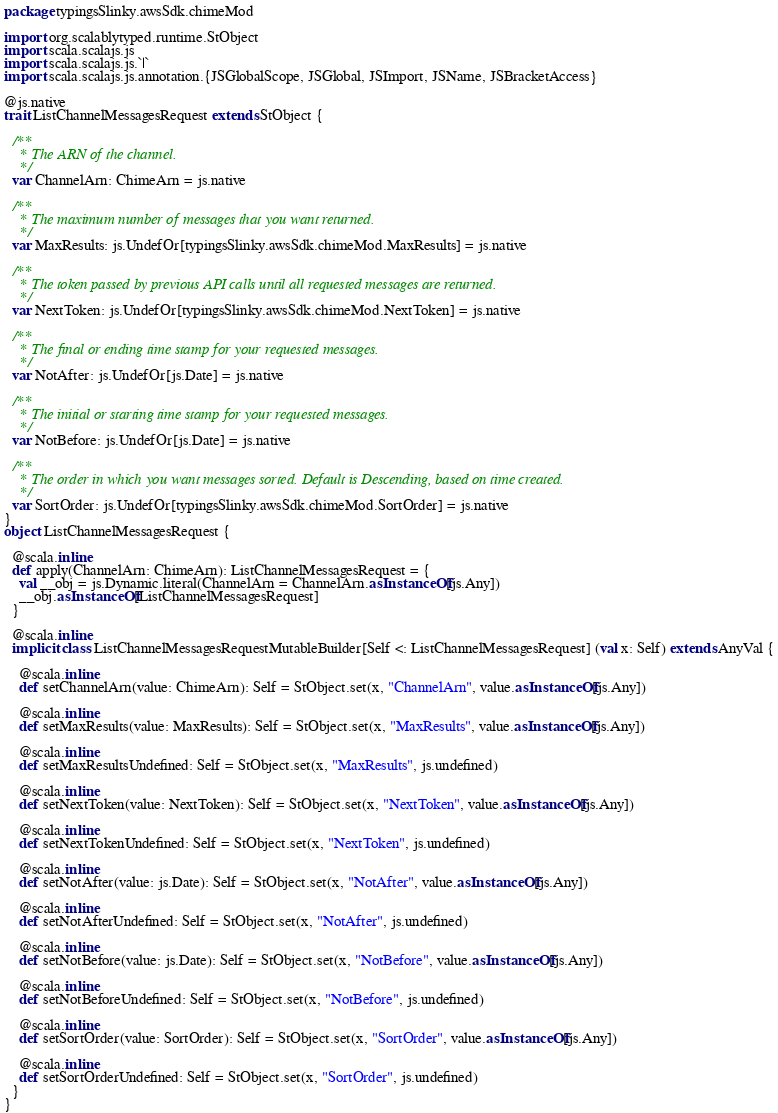<code> <loc_0><loc_0><loc_500><loc_500><_Scala_>package typingsSlinky.awsSdk.chimeMod

import org.scalablytyped.runtime.StObject
import scala.scalajs.js
import scala.scalajs.js.`|`
import scala.scalajs.js.annotation.{JSGlobalScope, JSGlobal, JSImport, JSName, JSBracketAccess}

@js.native
trait ListChannelMessagesRequest extends StObject {
  
  /**
    * The ARN of the channel.
    */
  var ChannelArn: ChimeArn = js.native
  
  /**
    * The maximum number of messages that you want returned.
    */
  var MaxResults: js.UndefOr[typingsSlinky.awsSdk.chimeMod.MaxResults] = js.native
  
  /**
    * The token passed by previous API calls until all requested messages are returned.
    */
  var NextToken: js.UndefOr[typingsSlinky.awsSdk.chimeMod.NextToken] = js.native
  
  /**
    * The final or ending time stamp for your requested messages.
    */
  var NotAfter: js.UndefOr[js.Date] = js.native
  
  /**
    * The initial or starting time stamp for your requested messages. 
    */
  var NotBefore: js.UndefOr[js.Date] = js.native
  
  /**
    * The order in which you want messages sorted. Default is Descending, based on time created.
    */
  var SortOrder: js.UndefOr[typingsSlinky.awsSdk.chimeMod.SortOrder] = js.native
}
object ListChannelMessagesRequest {
  
  @scala.inline
  def apply(ChannelArn: ChimeArn): ListChannelMessagesRequest = {
    val __obj = js.Dynamic.literal(ChannelArn = ChannelArn.asInstanceOf[js.Any])
    __obj.asInstanceOf[ListChannelMessagesRequest]
  }
  
  @scala.inline
  implicit class ListChannelMessagesRequestMutableBuilder[Self <: ListChannelMessagesRequest] (val x: Self) extends AnyVal {
    
    @scala.inline
    def setChannelArn(value: ChimeArn): Self = StObject.set(x, "ChannelArn", value.asInstanceOf[js.Any])
    
    @scala.inline
    def setMaxResults(value: MaxResults): Self = StObject.set(x, "MaxResults", value.asInstanceOf[js.Any])
    
    @scala.inline
    def setMaxResultsUndefined: Self = StObject.set(x, "MaxResults", js.undefined)
    
    @scala.inline
    def setNextToken(value: NextToken): Self = StObject.set(x, "NextToken", value.asInstanceOf[js.Any])
    
    @scala.inline
    def setNextTokenUndefined: Self = StObject.set(x, "NextToken", js.undefined)
    
    @scala.inline
    def setNotAfter(value: js.Date): Self = StObject.set(x, "NotAfter", value.asInstanceOf[js.Any])
    
    @scala.inline
    def setNotAfterUndefined: Self = StObject.set(x, "NotAfter", js.undefined)
    
    @scala.inline
    def setNotBefore(value: js.Date): Self = StObject.set(x, "NotBefore", value.asInstanceOf[js.Any])
    
    @scala.inline
    def setNotBeforeUndefined: Self = StObject.set(x, "NotBefore", js.undefined)
    
    @scala.inline
    def setSortOrder(value: SortOrder): Self = StObject.set(x, "SortOrder", value.asInstanceOf[js.Any])
    
    @scala.inline
    def setSortOrderUndefined: Self = StObject.set(x, "SortOrder", js.undefined)
  }
}
</code> 